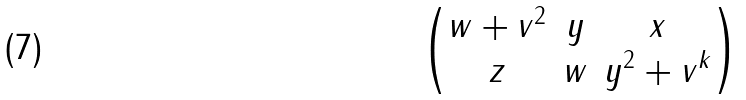<formula> <loc_0><loc_0><loc_500><loc_500>\begin{pmatrix} w + v ^ { 2 } & y & x \\ z & w & y ^ { 2 } + v ^ { k } \end{pmatrix}</formula> 